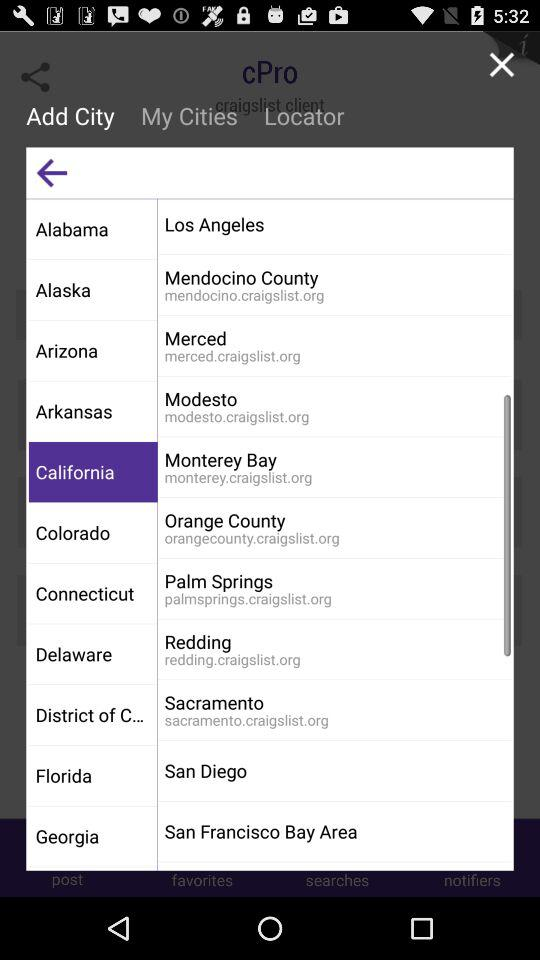In which state is the San Francisco Bay Area located? The state is California. 